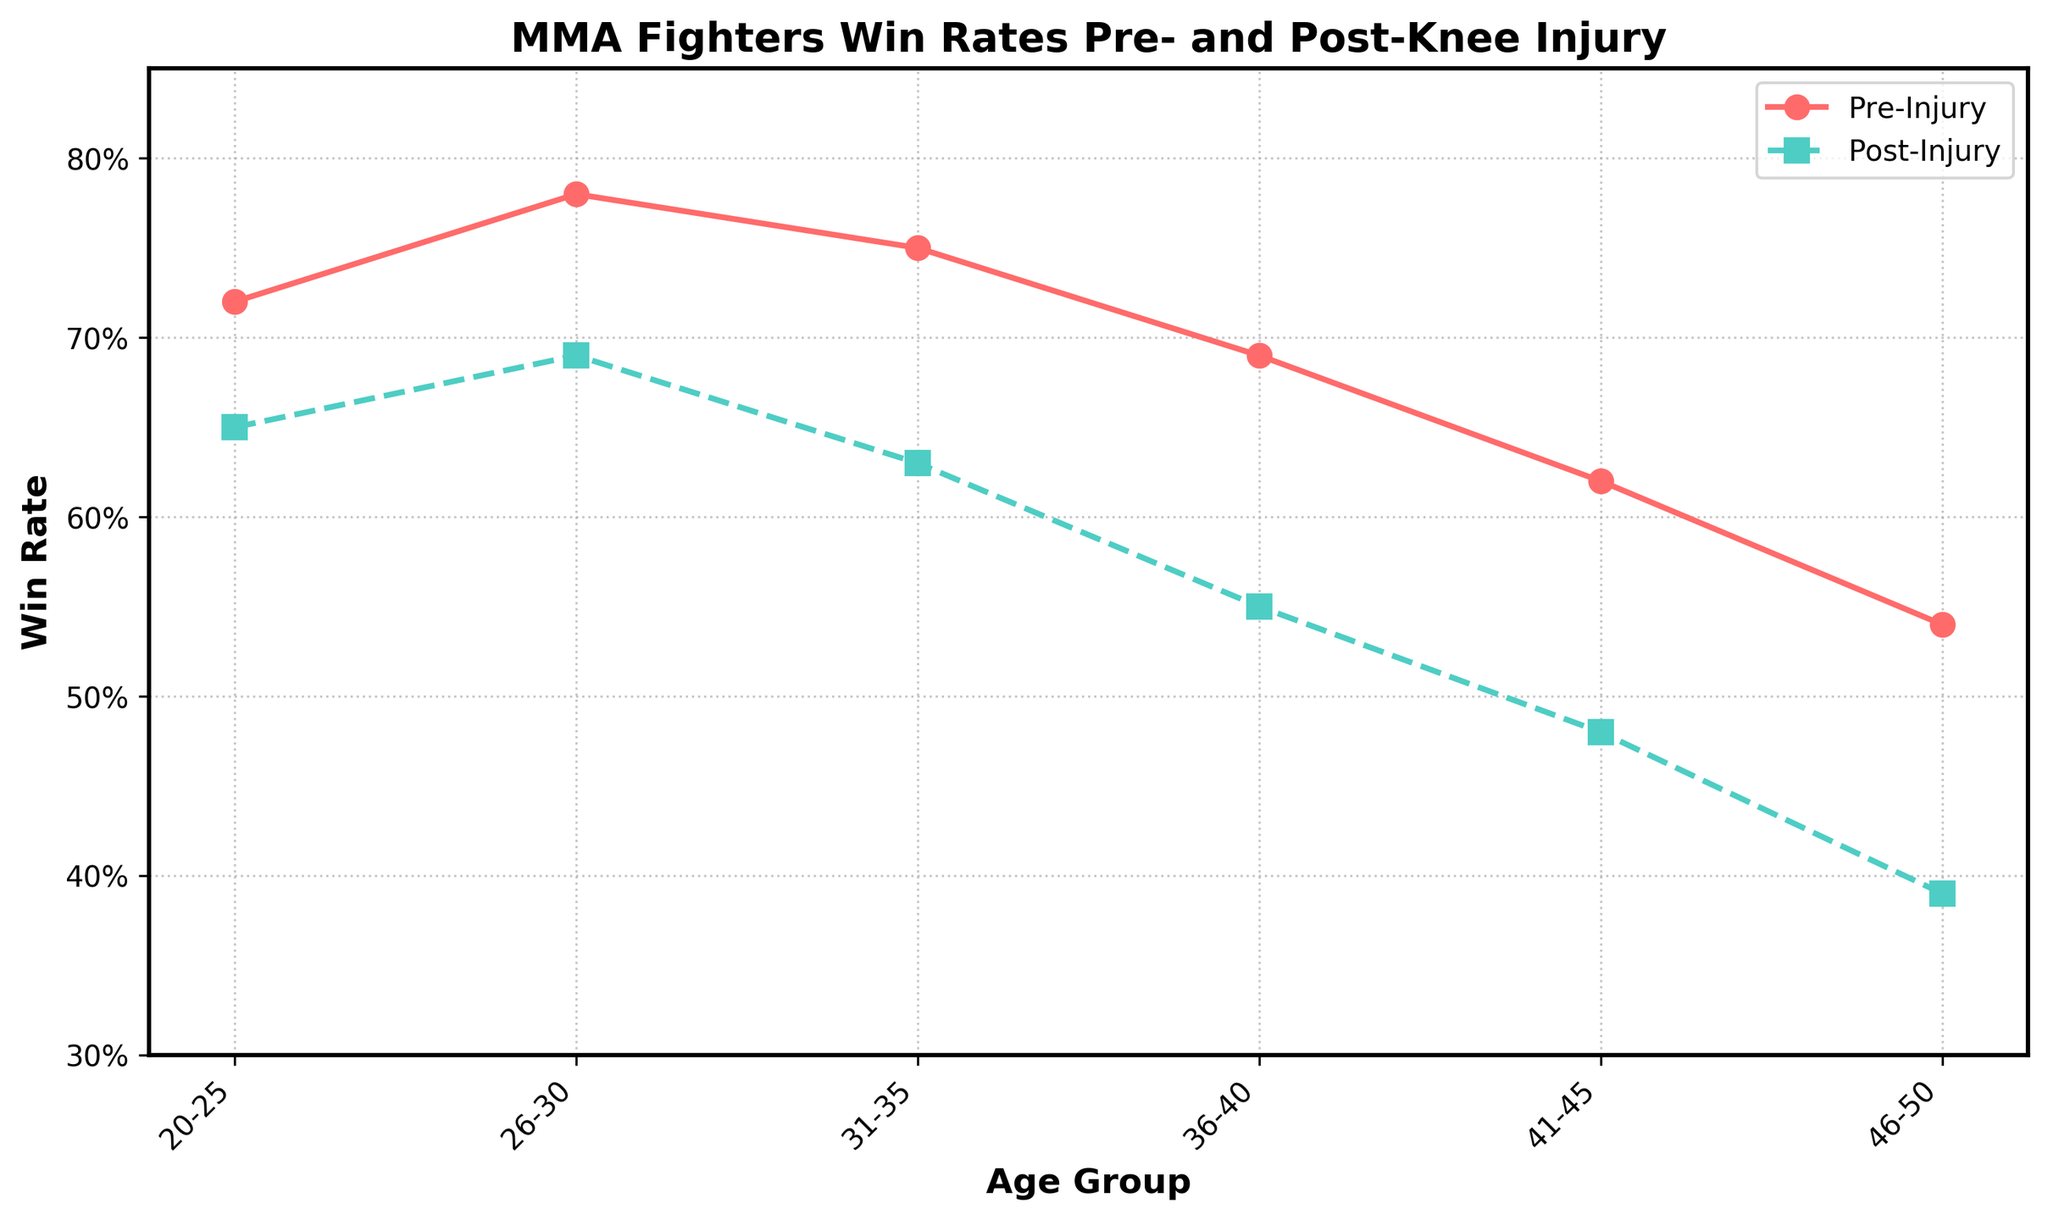What's the age group with the highest pre-injury win rate? The highest pre-injury win rate is found by looking at the peak of the solid line representing pre-injury win rates. The highest point is reached in the 26-30 age group.
Answer: 26-30 Which age group shows the largest drop in win rates from pre- to post-injury? Calculate the difference between pre- and post-injury win rates for each age group. The drop is calculated as follows: 20-25 = 0.72 - 0.65 = 0.07, 26-30 = 0.78 - 0.69 = 0.09, etc. The largest drop occurs in the 46-50 age group, with a difference of 0.54 - 0.39 = 0.15.
Answer: 46-50 What's the overall trend in win rates as the fighters age? Observe the graph lines across the age groups. Both the red (pre-injury) and green (post-injury) lines show a decreasing trend, indicating that win rates generally decline with age.
Answer: Decline By how much does the win rate decrease on average from pre- to post-injury across all age groups? Calculate the difference for each age group and then find the average. Differences are: 0.07, 0.09, 0.12, 0.14, 0.14, 0.15. Sum these: 0.07 + 0.09 + 0.12 + 0.14 + 0.14 + 0.15 = 0.71, and divide by 6 (number of age groups): 0.71 / 6 ≈ 0.1183.
Answer: 0.1183 By how much is the post-injury win rate for the 31-35 age group lower than the pre-injury win rate for the 20-25 age group? The 31-35 post-injury win rate is 0.63, and the 20-25 pre-injury win rate is 0.72. The difference is calculated as 0.72 - 0.63.
Answer: 0.09 Is there any age group where the drop in win rate from pre- to post-injury is less than 10%? Check the differences for each age group. The 20-25 age group has a difference of 0.07, which is less than 0.10 (10%). Other age groups have drops greater than 10%.
Answer: 20-25 What can be inferred visually from the markers used in the plot? The plot uses circles for pre-injury win rates and squares for post-injury win rates. This helps to visually differentiate the two datasets easily.
Answer: Circles and squares_used Which age group shows the smallest gap between pre- and post-injury win rates? Compare the differences for each age group. The smallest gap is 0.07, occurring in the 20-25 age group.
Answer: 20-25 